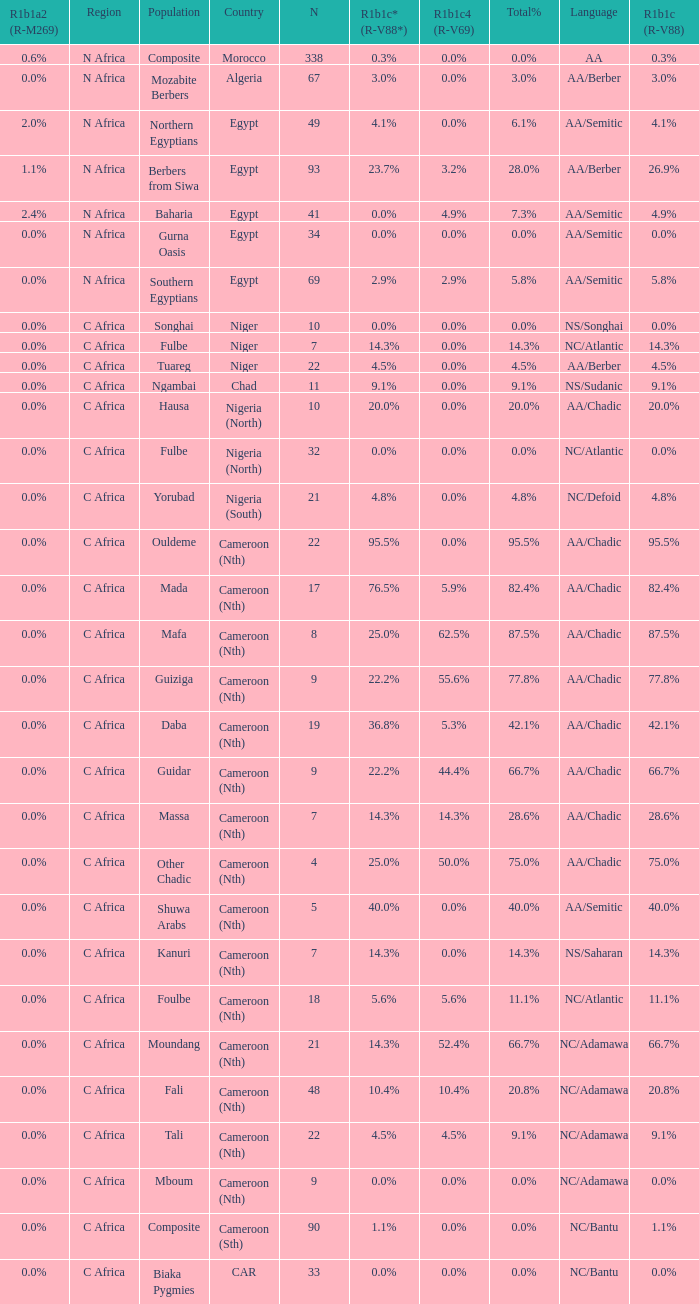How many n are recorded for 1.0. 